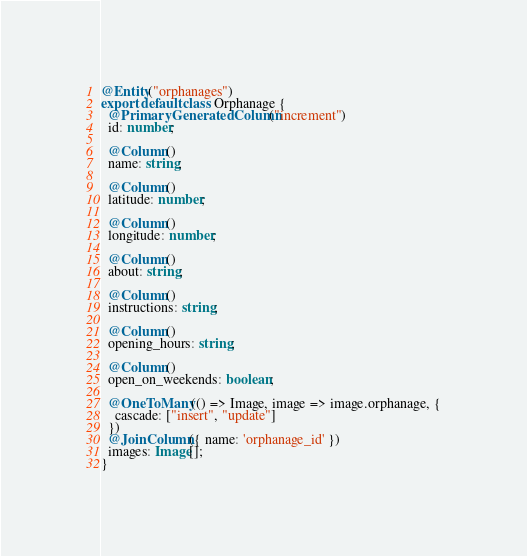<code> <loc_0><loc_0><loc_500><loc_500><_TypeScript_>@Entity("orphanages")
export default class Orphanage {
  @PrimaryGeneratedColumn("increment")
  id: number;

  @Column()
  name: string;

  @Column()
  latitude: number;

  @Column()
  longitude: number;

  @Column()
  about: string;

  @Column()
  instructions: string;

  @Column()
  opening_hours: string;

  @Column()
  open_on_weekends: boolean;

  @OneToMany(() => Image, image => image.orphanage, {
    cascade: ["insert", "update"]
  })
  @JoinColumn({ name: 'orphanage_id' })
  images: Image[];
}</code> 